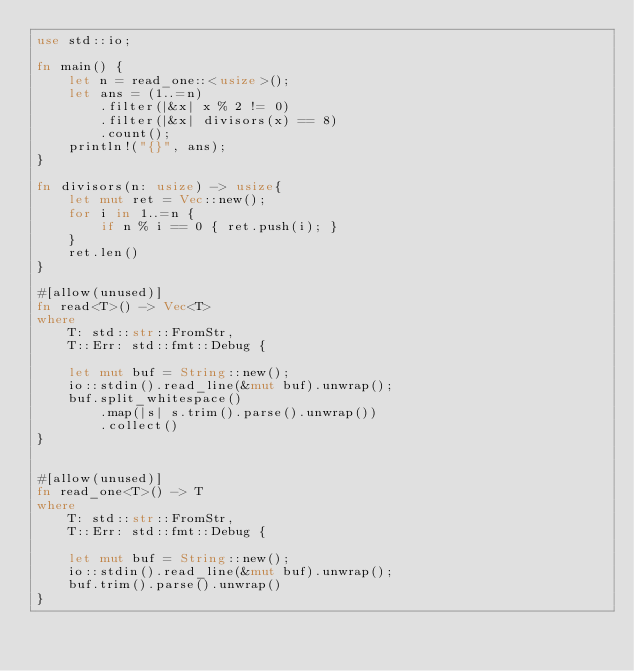<code> <loc_0><loc_0><loc_500><loc_500><_Rust_>use std::io;

fn main() {
    let n = read_one::<usize>();
    let ans = (1..=n)
        .filter(|&x| x % 2 != 0)
        .filter(|&x| divisors(x) == 8)
        .count();
    println!("{}", ans);
}

fn divisors(n: usize) -> usize{
    let mut ret = Vec::new();
    for i in 1..=n {
        if n % i == 0 { ret.push(i); }
    }
    ret.len()
}

#[allow(unused)]
fn read<T>() -> Vec<T>
where
    T: std::str::FromStr,
    T::Err: std::fmt::Debug {

    let mut buf = String::new();
    io::stdin().read_line(&mut buf).unwrap();
    buf.split_whitespace()
        .map(|s| s.trim().parse().unwrap())
        .collect()
}


#[allow(unused)]
fn read_one<T>() -> T
where
    T: std::str::FromStr,
    T::Err: std::fmt::Debug {

    let mut buf = String::new();
    io::stdin().read_line(&mut buf).unwrap();
    buf.trim().parse().unwrap()
}</code> 